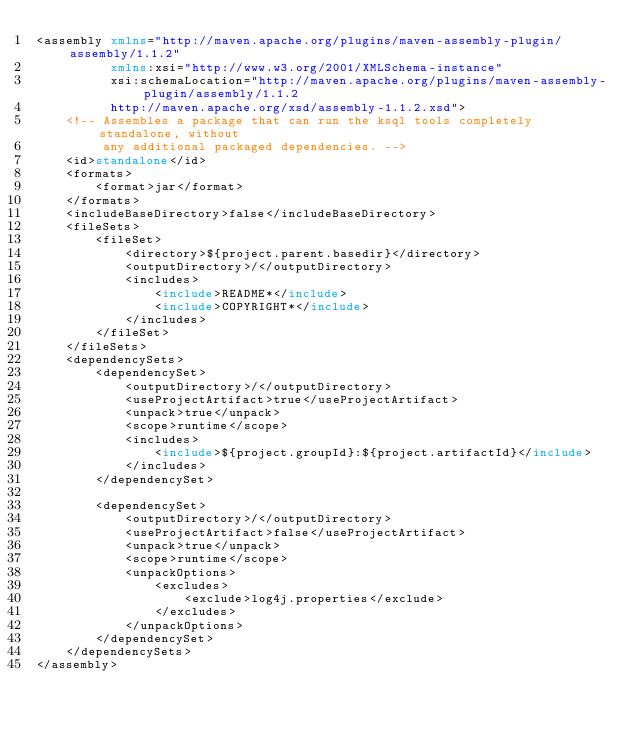<code> <loc_0><loc_0><loc_500><loc_500><_XML_><assembly xmlns="http://maven.apache.org/plugins/maven-assembly-plugin/assembly/1.1.2"
          xmlns:xsi="http://www.w3.org/2001/XMLSchema-instance"
          xsi:schemaLocation="http://maven.apache.org/plugins/maven-assembly-plugin/assembly/1.1.2
          http://maven.apache.org/xsd/assembly-1.1.2.xsd">
    <!-- Assembles a package that can run the ksql tools completely standalone, without
         any additional packaged dependencies. -->
    <id>standalone</id>
    <formats>
        <format>jar</format>
    </formats>
    <includeBaseDirectory>false</includeBaseDirectory>
    <fileSets>
        <fileSet>
            <directory>${project.parent.basedir}</directory>
            <outputDirectory>/</outputDirectory>
            <includes>
                <include>README*</include>
                <include>COPYRIGHT*</include>
            </includes>
        </fileSet>
    </fileSets>
    <dependencySets>
        <dependencySet>
            <outputDirectory>/</outputDirectory>
            <useProjectArtifact>true</useProjectArtifact>
            <unpack>true</unpack>
            <scope>runtime</scope>
            <includes>
                <include>${project.groupId}:${project.artifactId}</include>
            </includes>
        </dependencySet>

        <dependencySet>
            <outputDirectory>/</outputDirectory>
            <useProjectArtifact>false</useProjectArtifact>
            <unpack>true</unpack>
            <scope>runtime</scope>
            <unpackOptions>
                <excludes>
                    <exclude>log4j.properties</exclude>
                </excludes>
            </unpackOptions>
        </dependencySet>
    </dependencySets>
</assembly>
</code> 